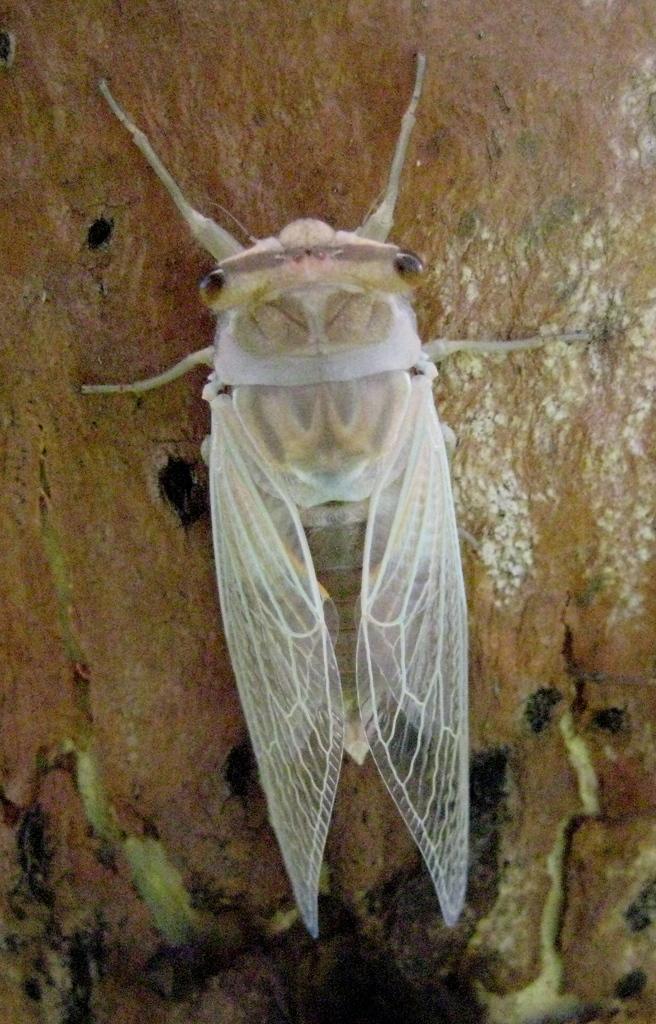How would you summarize this image in a sentence or two? Here I can see an insect on a wooden surface. 